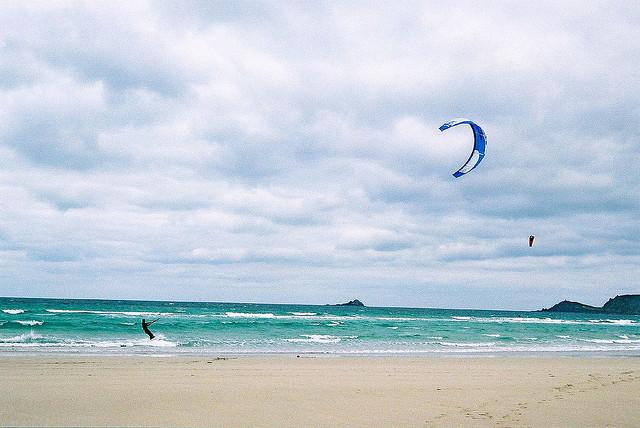Where was this picture taken?
Concise answer only. Beach. What is covering the ground?
Be succinct. Sand. What powers the sail?
Write a very short answer. Wind. 